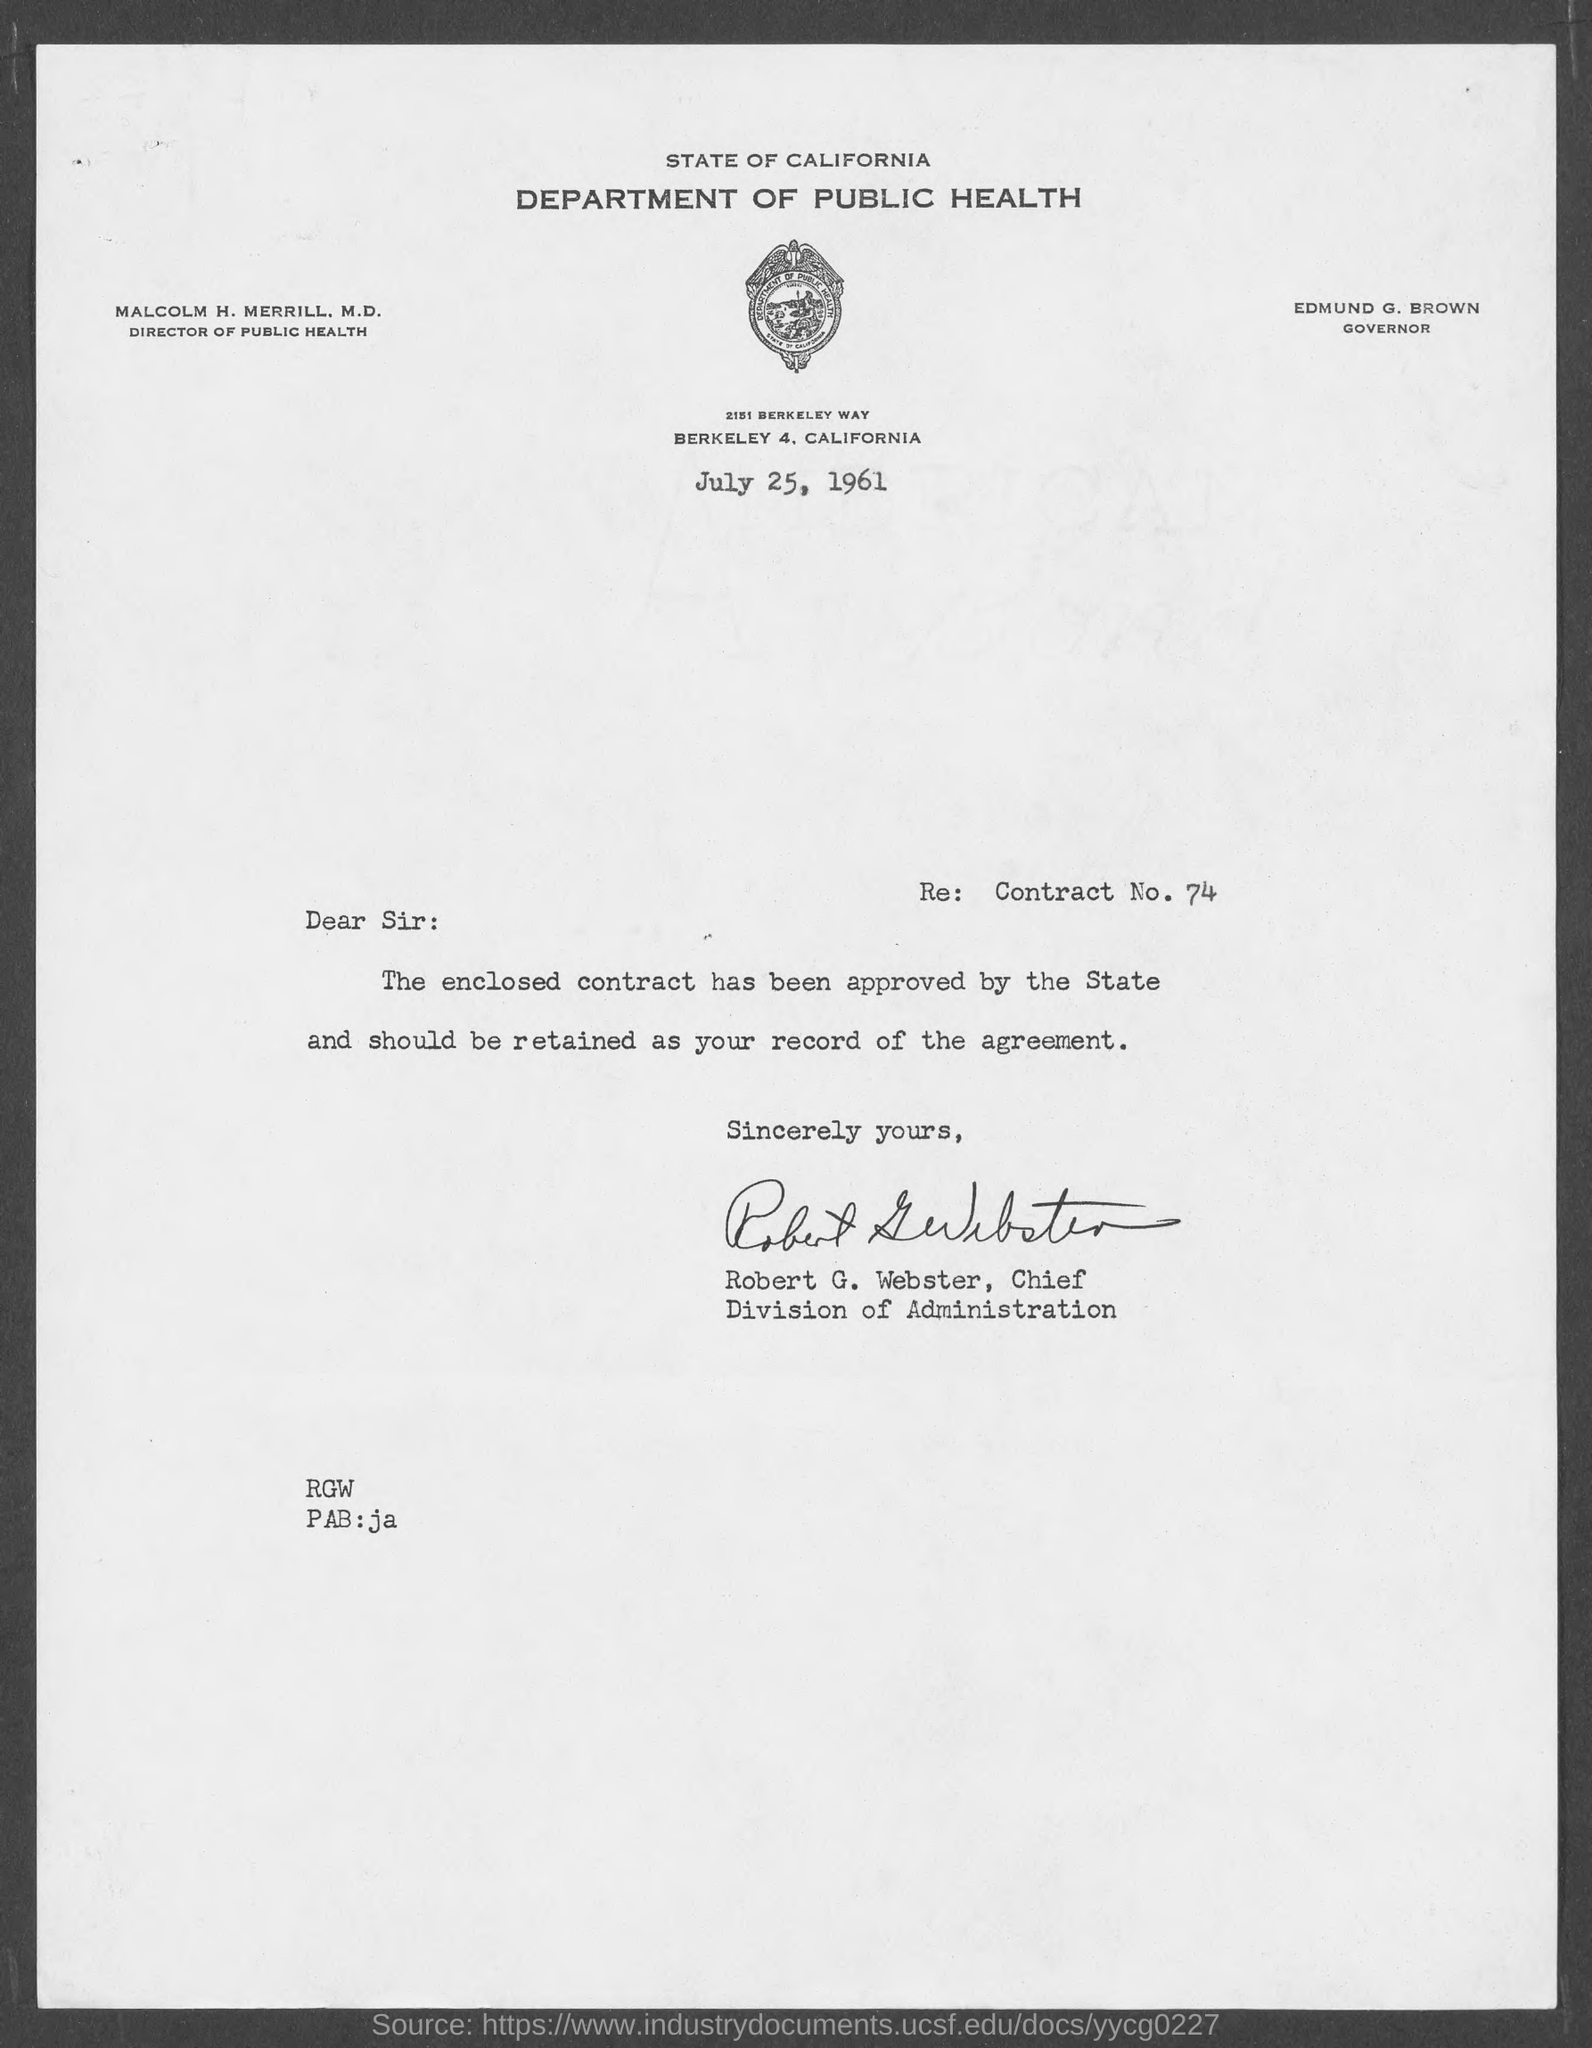Who was the GOVERNOR for STATE OF CALIFORNIA DEPARTMENT OF HEALTH?
Your answer should be very brief. EDMUND G. BROWN. Whats the Designation of MALCOLM H. MERRILL,M.D in DEPARTMENT OF PUBLIC HEALTH?
Ensure brevity in your answer.  Director of public health. When this letter was sent?
Offer a very short reply. July 25, 1961. Whats the Contract No.?
Give a very brief answer. 74. Who sent this letter?
Provide a short and direct response. Robert g. webster. 